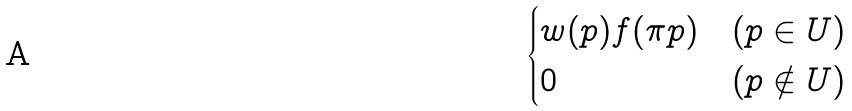<formula> <loc_0><loc_0><loc_500><loc_500>\begin{cases} w ( p ) f ( \pi p ) & ( p \in U ) \\ 0 & ( p \notin U ) \end{cases}</formula> 